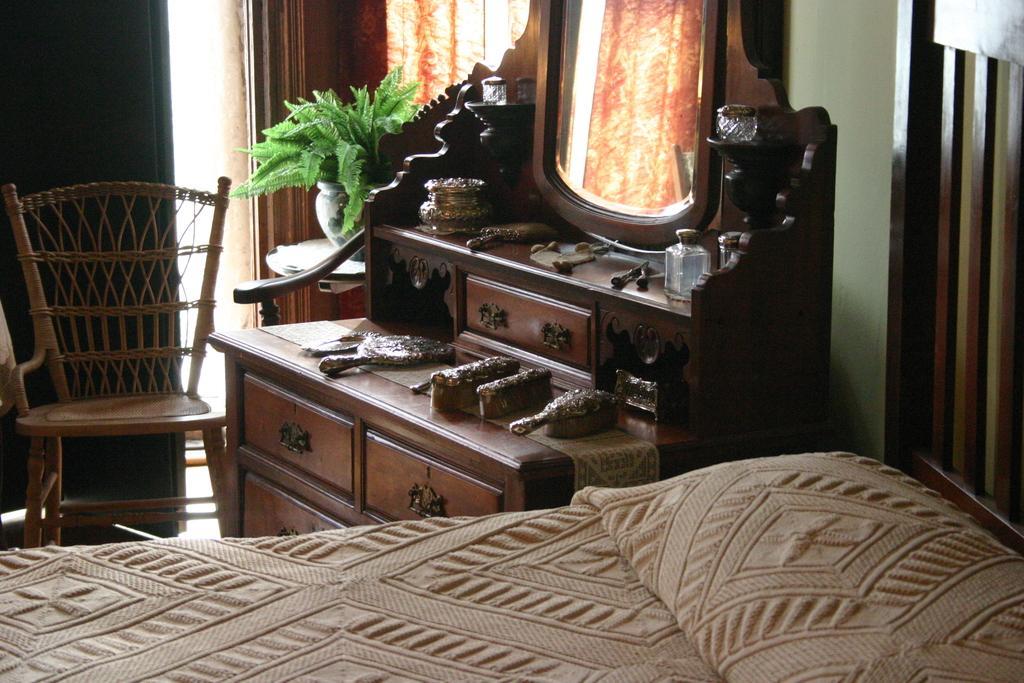Please provide a concise description of this image. In this image I can see a bed, a chair, a plant and a dressing table. 